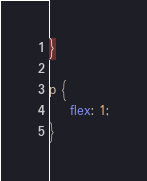Convert code to text. <code><loc_0><loc_0><loc_500><loc_500><_CSS_>}

p {
	flex: 1;
}</code> 